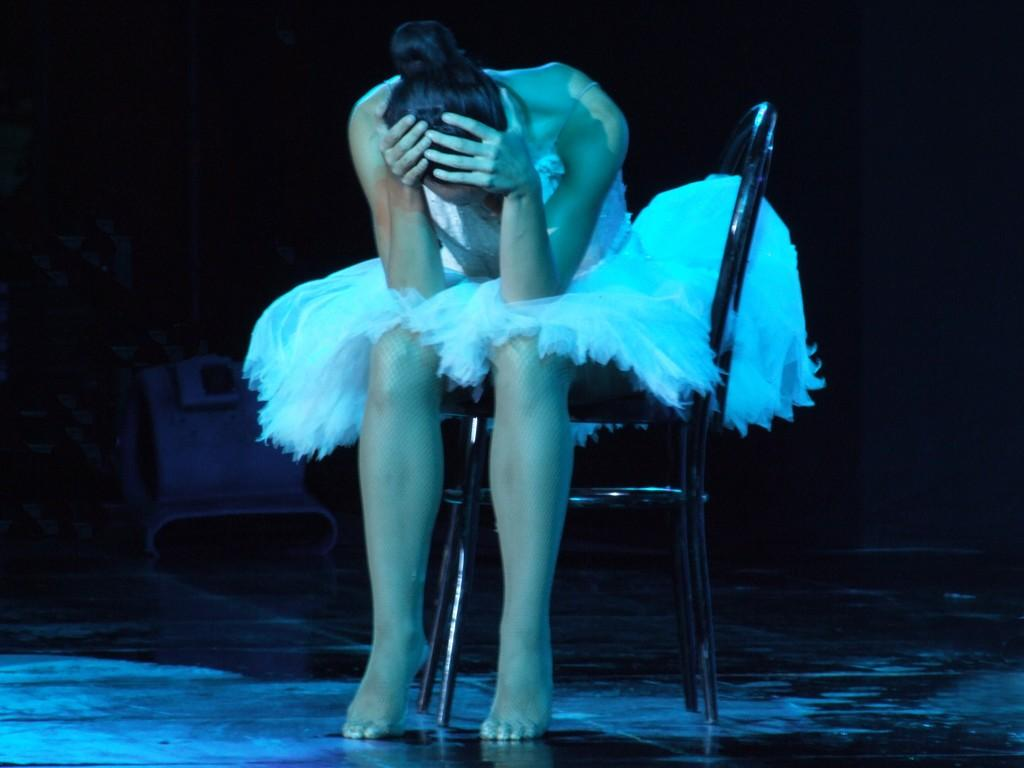Who is the main subject in the image? There is a woman in the image. What is the woman doing in the image? The woman is sitting on a chair. What can be observed about the background of the image? The background of the image is dark. What type of butter is the woman using to support her team in the image? There is no butter or team present in the image; it features a woman sitting on a chair with a dark background. 